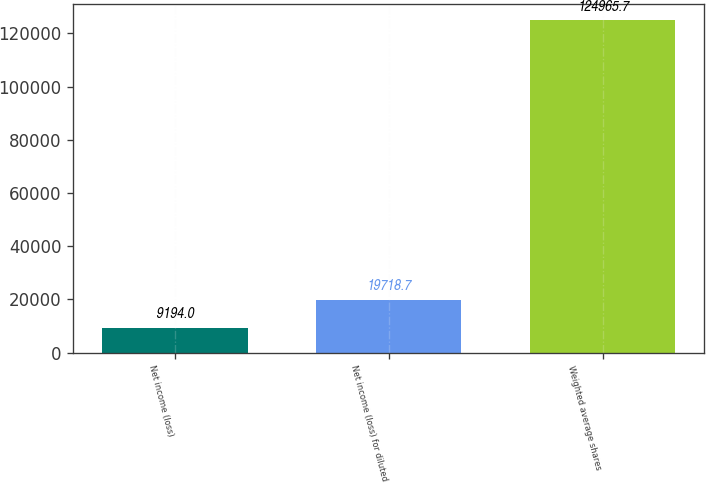Convert chart. <chart><loc_0><loc_0><loc_500><loc_500><bar_chart><fcel>Net income (loss)<fcel>Net income (loss) for diluted<fcel>Weighted average shares<nl><fcel>9194<fcel>19718.7<fcel>124966<nl></chart> 